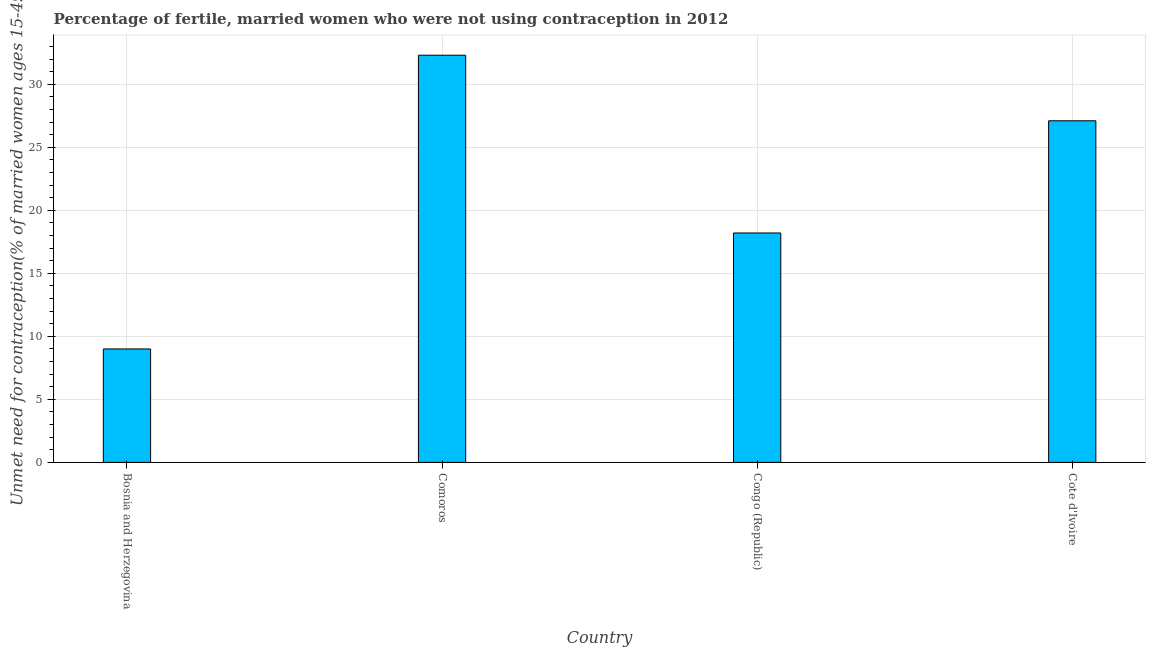Does the graph contain any zero values?
Give a very brief answer. No. Does the graph contain grids?
Offer a terse response. Yes. What is the title of the graph?
Keep it short and to the point. Percentage of fertile, married women who were not using contraception in 2012. What is the label or title of the Y-axis?
Offer a very short reply.  Unmet need for contraception(% of married women ages 15-49). Across all countries, what is the maximum number of married women who are not using contraception?
Offer a terse response. 32.3. In which country was the number of married women who are not using contraception maximum?
Make the answer very short. Comoros. In which country was the number of married women who are not using contraception minimum?
Give a very brief answer. Bosnia and Herzegovina. What is the sum of the number of married women who are not using contraception?
Give a very brief answer. 86.6. What is the average number of married women who are not using contraception per country?
Your response must be concise. 21.65. What is the median number of married women who are not using contraception?
Keep it short and to the point. 22.65. In how many countries, is the number of married women who are not using contraception greater than 17 %?
Ensure brevity in your answer.  3. What is the ratio of the number of married women who are not using contraception in Bosnia and Herzegovina to that in Cote d'Ivoire?
Provide a succinct answer. 0.33. What is the difference between the highest and the second highest number of married women who are not using contraception?
Your response must be concise. 5.2. Is the sum of the number of married women who are not using contraception in Comoros and Cote d'Ivoire greater than the maximum number of married women who are not using contraception across all countries?
Provide a short and direct response. Yes. What is the difference between the highest and the lowest number of married women who are not using contraception?
Provide a short and direct response. 23.3. In how many countries, is the number of married women who are not using contraception greater than the average number of married women who are not using contraception taken over all countries?
Ensure brevity in your answer.  2. Are all the bars in the graph horizontal?
Provide a succinct answer. No. What is the difference between two consecutive major ticks on the Y-axis?
Give a very brief answer. 5. What is the  Unmet need for contraception(% of married women ages 15-49) of Bosnia and Herzegovina?
Offer a terse response. 9. What is the  Unmet need for contraception(% of married women ages 15-49) in Comoros?
Provide a short and direct response. 32.3. What is the  Unmet need for contraception(% of married women ages 15-49) of Congo (Republic)?
Your answer should be compact. 18.2. What is the  Unmet need for contraception(% of married women ages 15-49) in Cote d'Ivoire?
Make the answer very short. 27.1. What is the difference between the  Unmet need for contraception(% of married women ages 15-49) in Bosnia and Herzegovina and Comoros?
Your answer should be compact. -23.3. What is the difference between the  Unmet need for contraception(% of married women ages 15-49) in Bosnia and Herzegovina and Congo (Republic)?
Offer a terse response. -9.2. What is the difference between the  Unmet need for contraception(% of married women ages 15-49) in Bosnia and Herzegovina and Cote d'Ivoire?
Provide a succinct answer. -18.1. What is the difference between the  Unmet need for contraception(% of married women ages 15-49) in Comoros and Congo (Republic)?
Make the answer very short. 14.1. What is the difference between the  Unmet need for contraception(% of married women ages 15-49) in Congo (Republic) and Cote d'Ivoire?
Give a very brief answer. -8.9. What is the ratio of the  Unmet need for contraception(% of married women ages 15-49) in Bosnia and Herzegovina to that in Comoros?
Ensure brevity in your answer.  0.28. What is the ratio of the  Unmet need for contraception(% of married women ages 15-49) in Bosnia and Herzegovina to that in Congo (Republic)?
Provide a short and direct response. 0.49. What is the ratio of the  Unmet need for contraception(% of married women ages 15-49) in Bosnia and Herzegovina to that in Cote d'Ivoire?
Ensure brevity in your answer.  0.33. What is the ratio of the  Unmet need for contraception(% of married women ages 15-49) in Comoros to that in Congo (Republic)?
Your response must be concise. 1.77. What is the ratio of the  Unmet need for contraception(% of married women ages 15-49) in Comoros to that in Cote d'Ivoire?
Offer a terse response. 1.19. What is the ratio of the  Unmet need for contraception(% of married women ages 15-49) in Congo (Republic) to that in Cote d'Ivoire?
Keep it short and to the point. 0.67. 